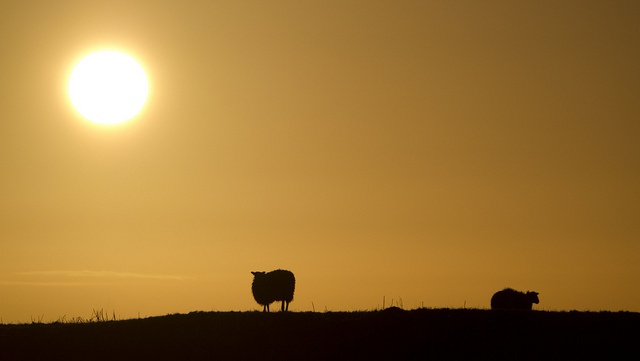Describe the objects in this image and their specific colors. I can see sheep in olive, black, and maroon tones and sheep in olive, black, and maroon tones in this image. 